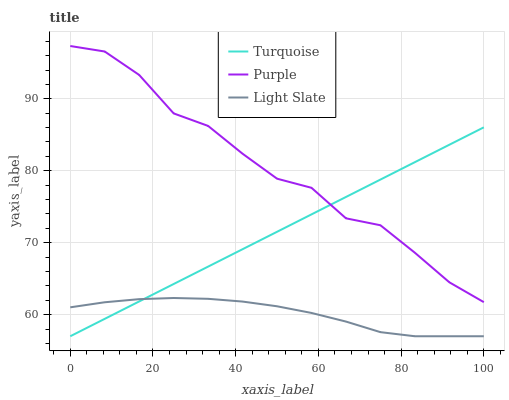Does Light Slate have the minimum area under the curve?
Answer yes or no. Yes. Does Purple have the maximum area under the curve?
Answer yes or no. Yes. Does Turquoise have the minimum area under the curve?
Answer yes or no. No. Does Turquoise have the maximum area under the curve?
Answer yes or no. No. Is Turquoise the smoothest?
Answer yes or no. Yes. Is Purple the roughest?
Answer yes or no. Yes. Is Light Slate the smoothest?
Answer yes or no. No. Is Light Slate the roughest?
Answer yes or no. No. Does Light Slate have the lowest value?
Answer yes or no. Yes. Does Purple have the highest value?
Answer yes or no. Yes. Does Turquoise have the highest value?
Answer yes or no. No. Is Light Slate less than Purple?
Answer yes or no. Yes. Is Purple greater than Light Slate?
Answer yes or no. Yes. Does Purple intersect Turquoise?
Answer yes or no. Yes. Is Purple less than Turquoise?
Answer yes or no. No. Is Purple greater than Turquoise?
Answer yes or no. No. Does Light Slate intersect Purple?
Answer yes or no. No. 